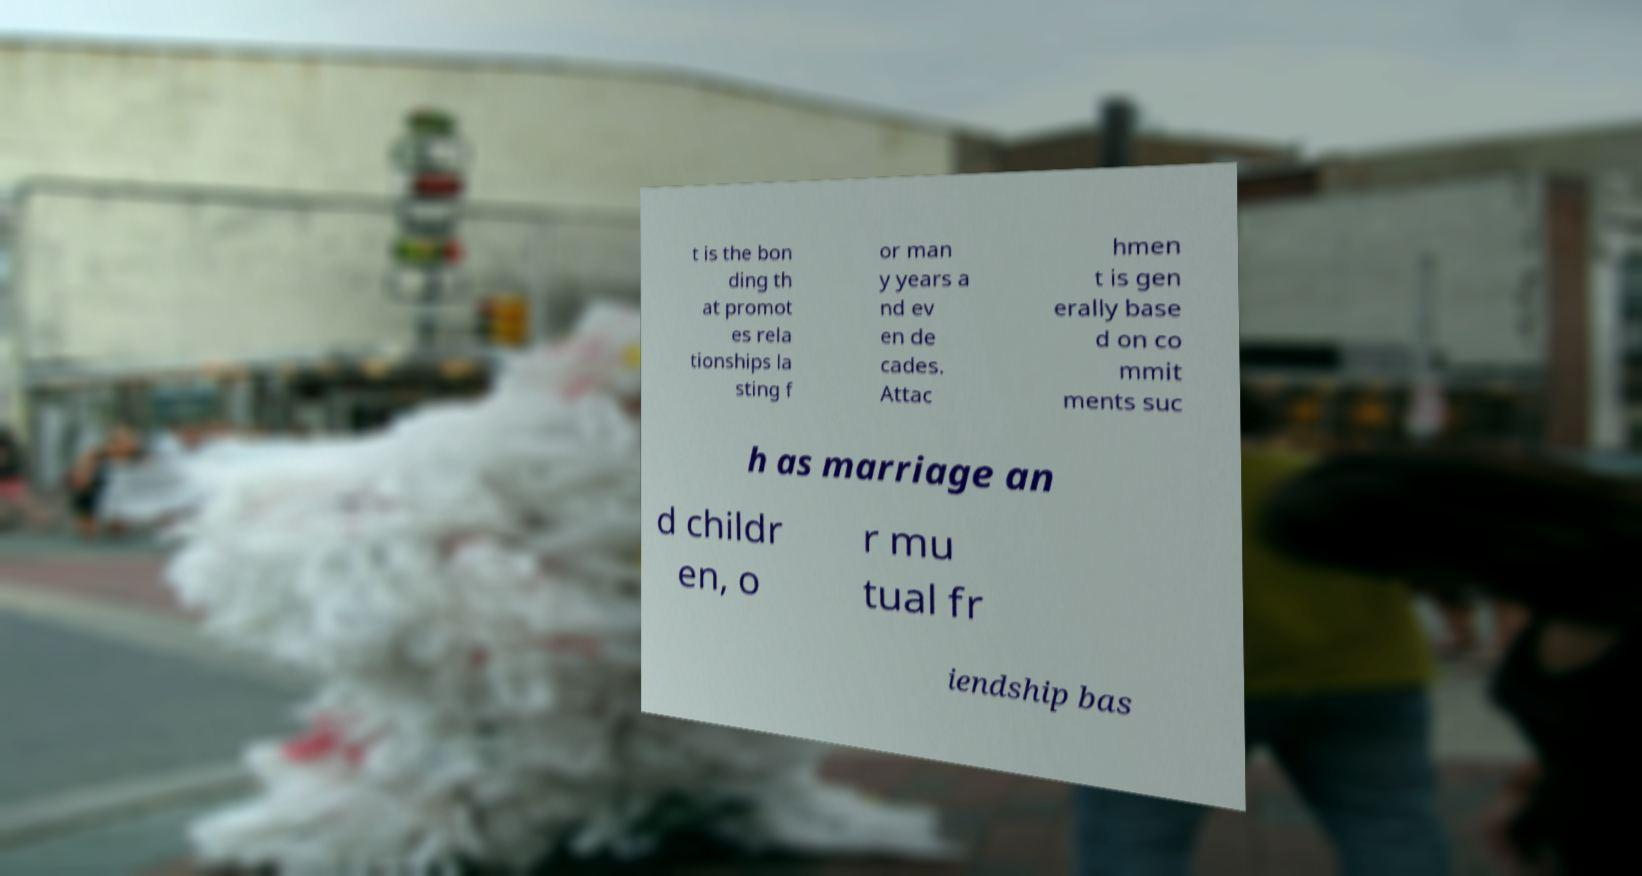Please identify and transcribe the text found in this image. t is the bon ding th at promot es rela tionships la sting f or man y years a nd ev en de cades. Attac hmen t is gen erally base d on co mmit ments suc h as marriage an d childr en, o r mu tual fr iendship bas 